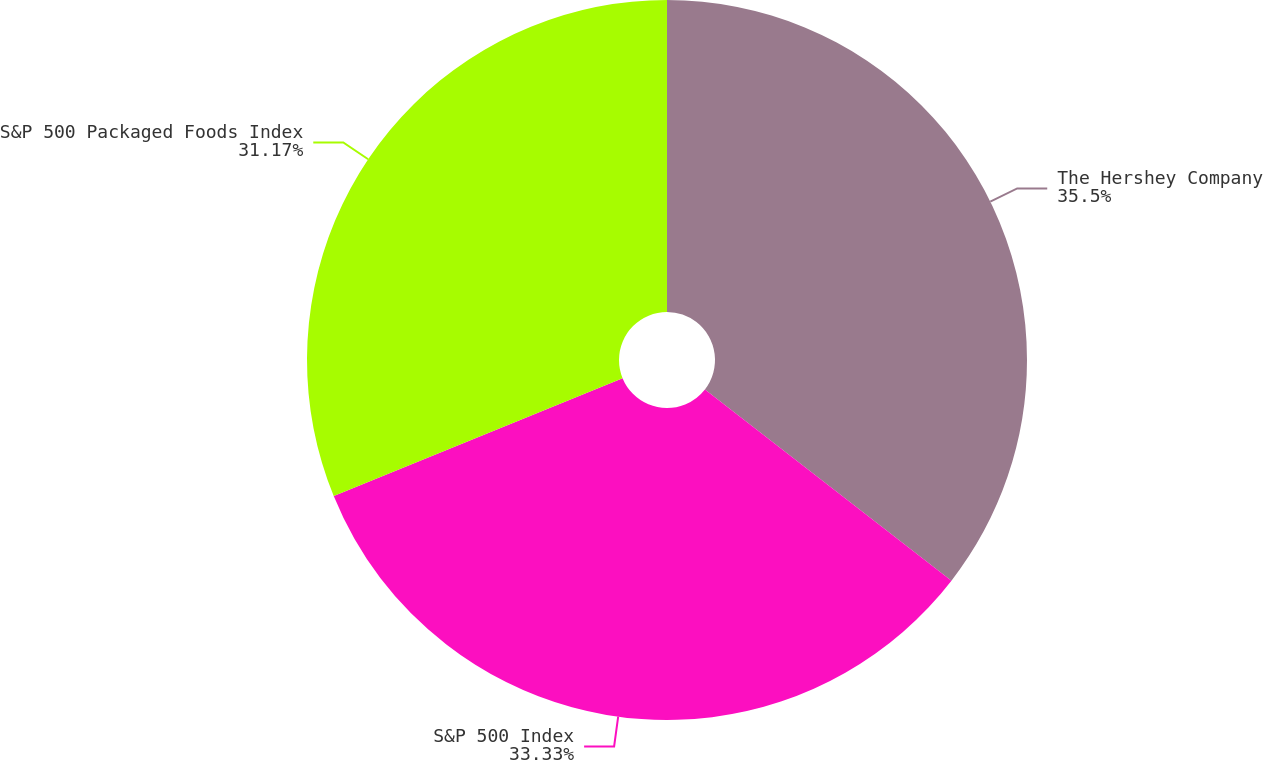<chart> <loc_0><loc_0><loc_500><loc_500><pie_chart><fcel>The Hershey Company<fcel>S&P 500 Index<fcel>S&P 500 Packaged Foods Index<nl><fcel>35.5%<fcel>33.33%<fcel>31.17%<nl></chart> 